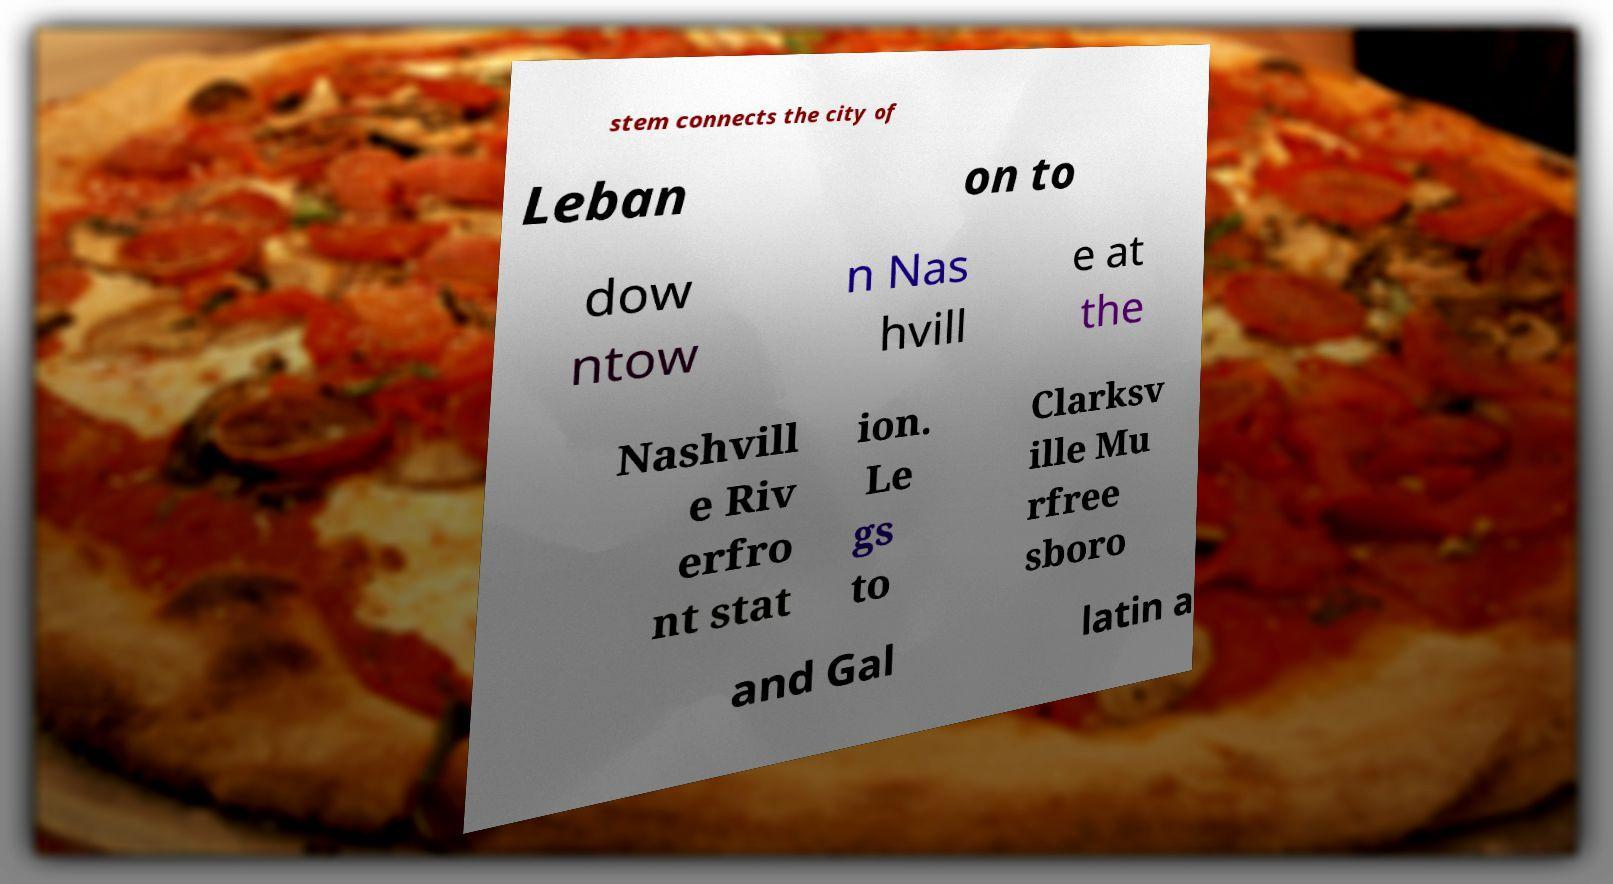What messages or text are displayed in this image? I need them in a readable, typed format. stem connects the city of Leban on to dow ntow n Nas hvill e at the Nashvill e Riv erfro nt stat ion. Le gs to Clarksv ille Mu rfree sboro and Gal latin a 